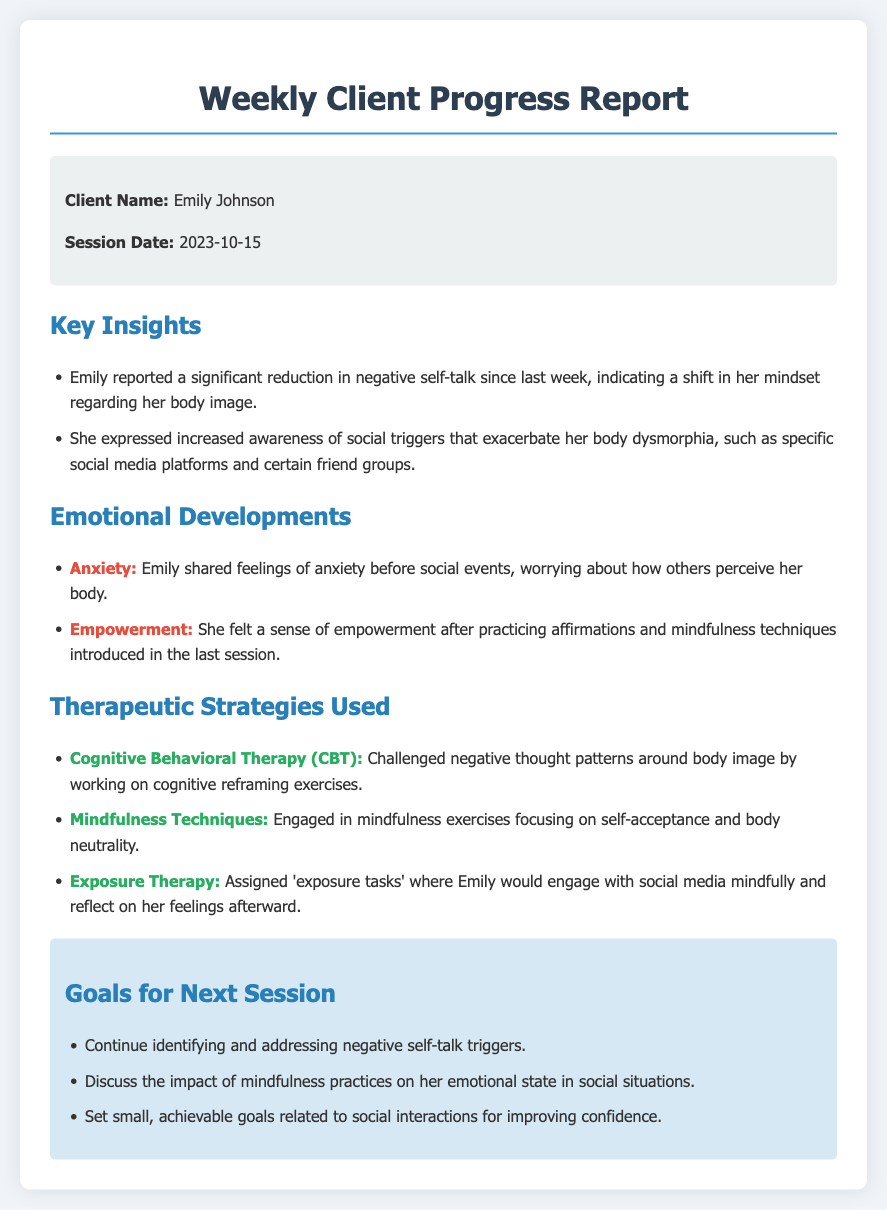What is the client's name? The client's name is mentioned in the client information section of the document.
Answer: Emily Johnson What date was the session? The date of the session is specified in the client information section of the document.
Answer: 2023-10-15 What emotional feeling did Emily share related to social events? Emily's emotional development indicates her feelings regarding social situations are detailed here.
Answer: Anxiety Which therapeutic strategy involved challenging negative thought patterns? The specific strategy for addressing negative thoughts is listed among the therapeutic strategies.
Answer: Cognitive Behavioral Therapy (CBT) What significant reduction did Emily report since last week? This insight is outlined in the key insights section regarding her self-perception.
Answer: Negative self-talk Name one mindfulness technique used in therapy. The document highlights various techniques, one of which is presented under therapeutic strategies.
Answer: Mindfulness Techniques How many goals are set for the next session? The number of distinct goals for the next session can be found in the goals section of the document.
Answer: Three What sense did Emily feel after practicing affirmations? This emotional development reflects her progress in therapy after mindfulness practices.
Answer: Empowerment Which social triggers does Emily mention that affect her body dysmorphia? The key insight section states her awareness of those social triggers affecting her mindset.
Answer: Social media platforms 